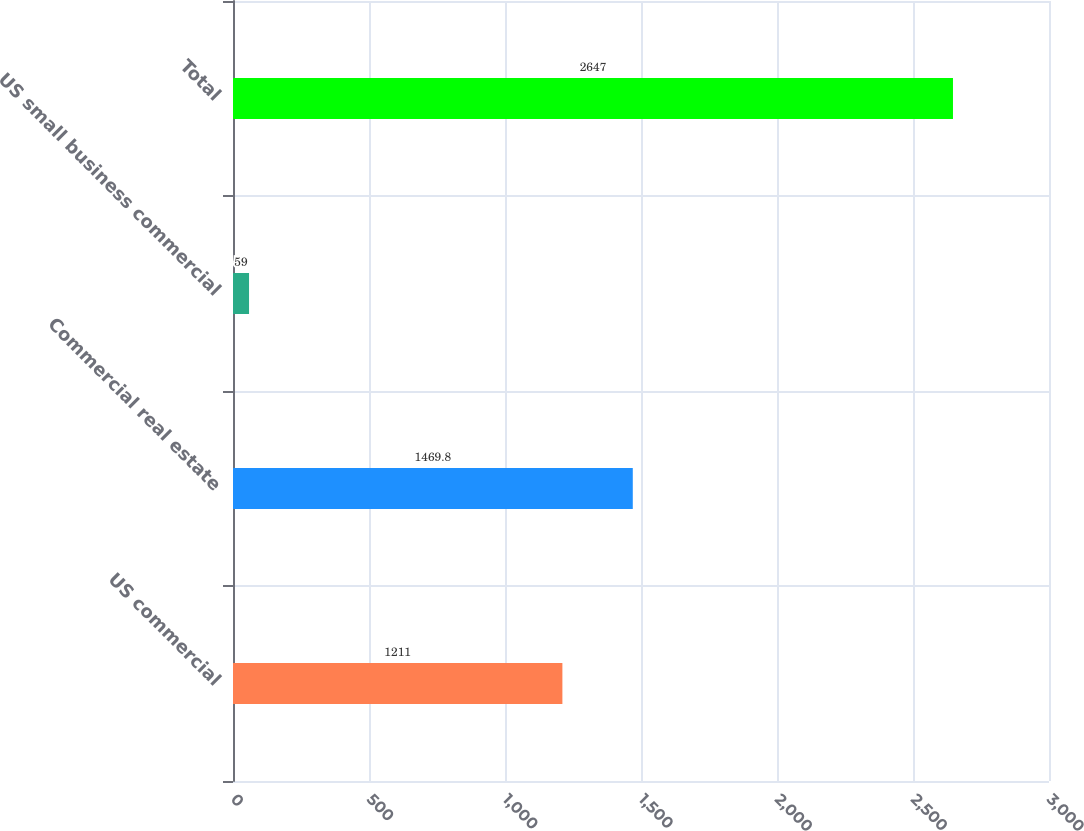Convert chart to OTSL. <chart><loc_0><loc_0><loc_500><loc_500><bar_chart><fcel>US commercial<fcel>Commercial real estate<fcel>US small business commercial<fcel>Total<nl><fcel>1211<fcel>1469.8<fcel>59<fcel>2647<nl></chart> 